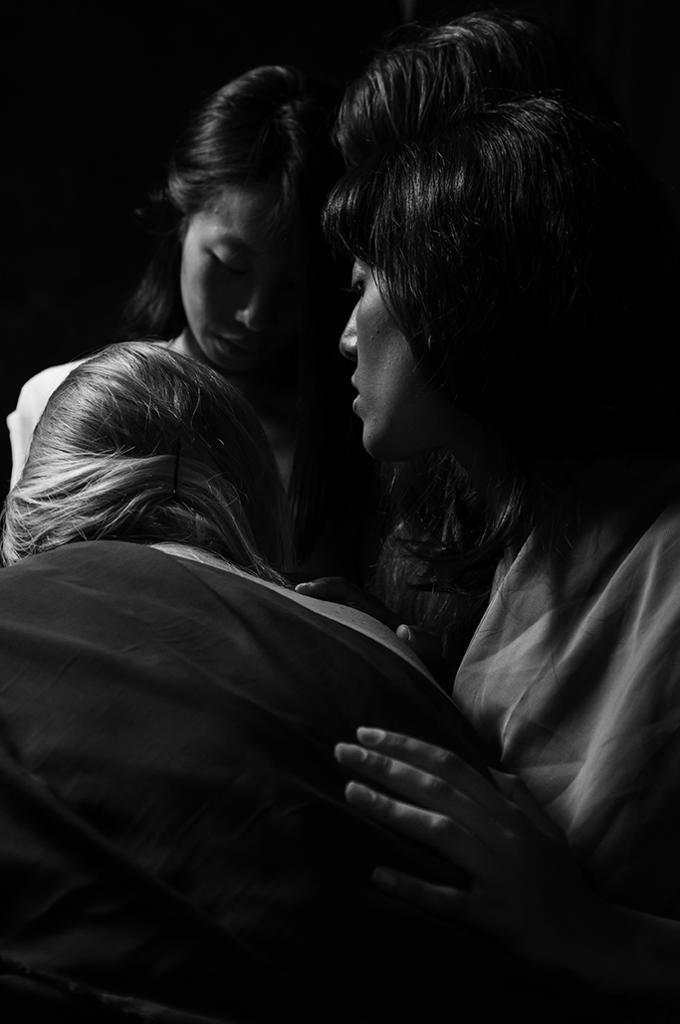Describe this image in one or two sentences. This is a black and white image. In this image there are three people standing. The background is dark. 